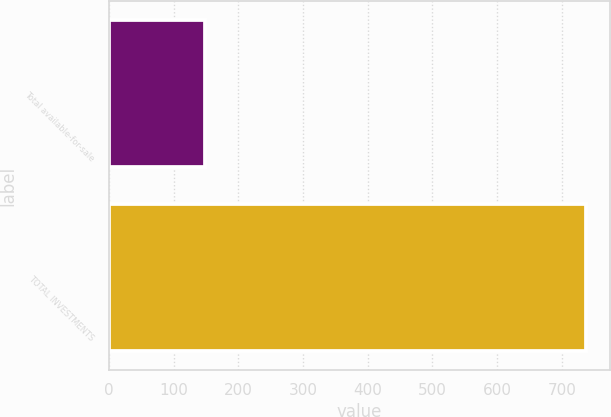Convert chart to OTSL. <chart><loc_0><loc_0><loc_500><loc_500><bar_chart><fcel>Total available-for-sale<fcel>TOTAL INVESTMENTS<nl><fcel>148<fcel>737<nl></chart> 